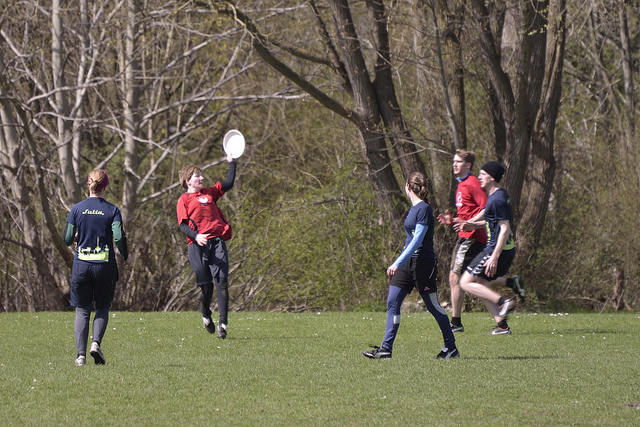Identify the text displayed in this image. 8 